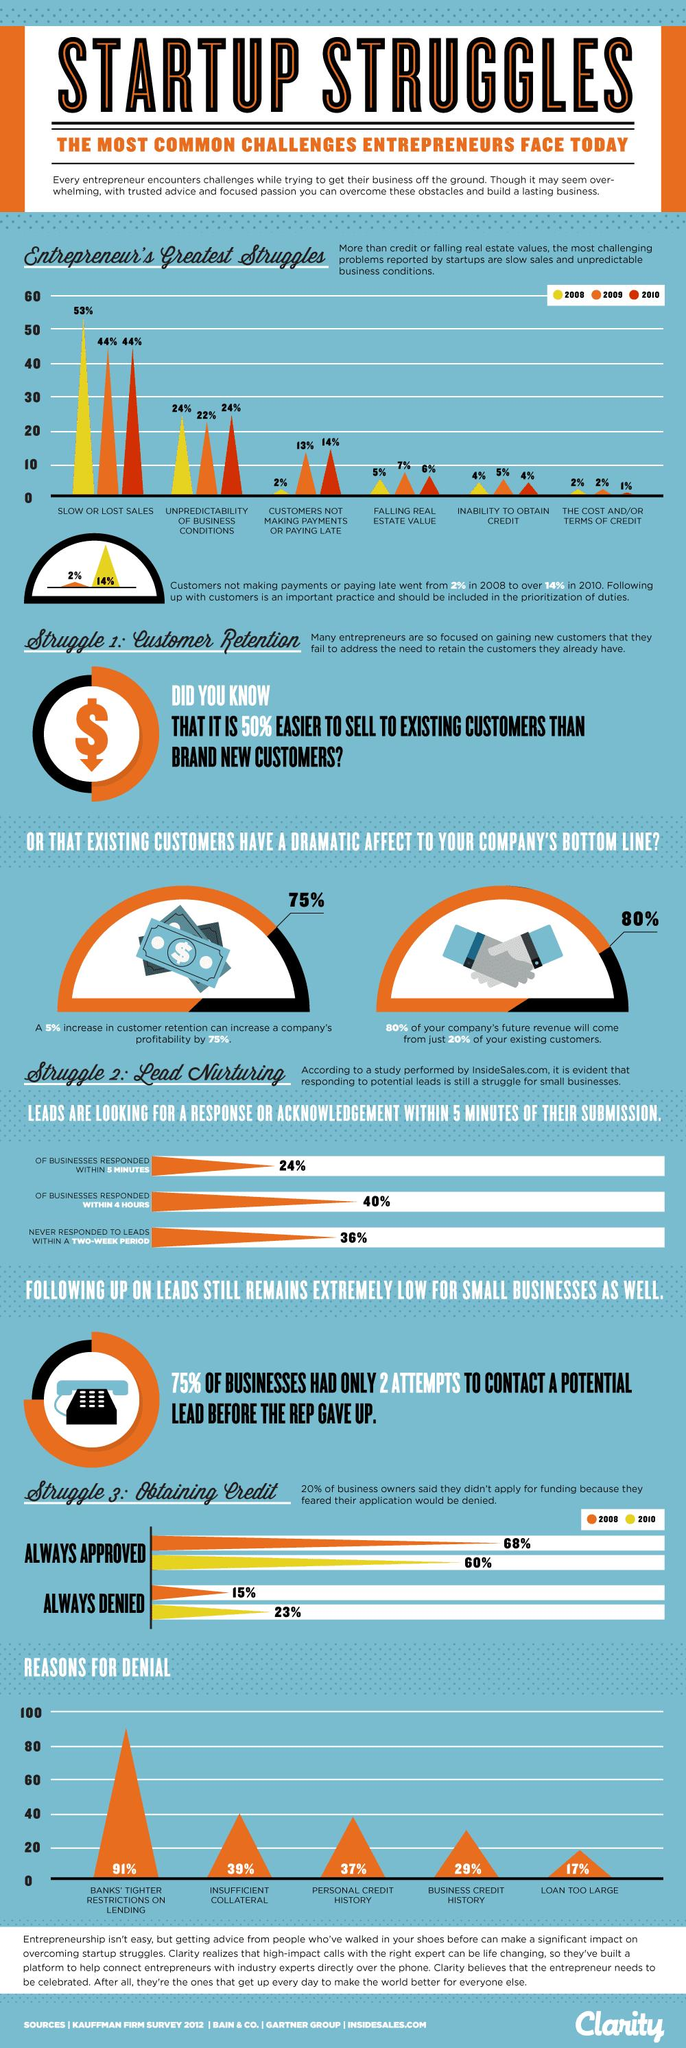Mention a couple of crucial points in this snapshot. The percentage difference in credits being denied due to insufficient collateral and personal credit history is 1%. According to a study conducted in 2010, 24% of businesses reported being negatively affected by the uncertain business environment. According to a 2009 study, a shocking 5% of entrepreneurs were unable to obtain credit, indicating the significant challenges they faced in securing the financial resources necessary to start and grow their businesses. A substantial number of businesses, approximately 76%, do not reply to leads within 5 minutes. In 2008, it was reported that only 2% of entrepreneurs did not receive payments. 